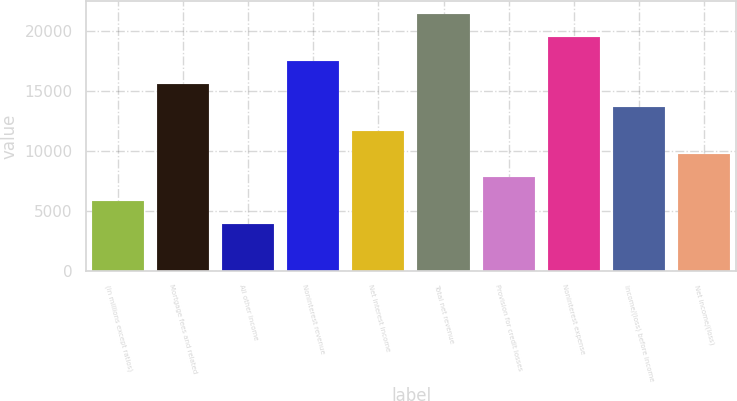<chart> <loc_0><loc_0><loc_500><loc_500><bar_chart><fcel>(in millions except ratios)<fcel>Mortgage fees and related<fcel>All other income<fcel>Noninterest revenue<fcel>Net interest income<fcel>Total net revenue<fcel>Provision for credit losses<fcel>Noninterest expense<fcel>Income/(loss) before income<fcel>Net income/(loss)<nl><fcel>5861.2<fcel>15603.2<fcel>3912.8<fcel>17551.6<fcel>11706.4<fcel>21448.4<fcel>7809.6<fcel>19500<fcel>13654.8<fcel>9758<nl></chart> 